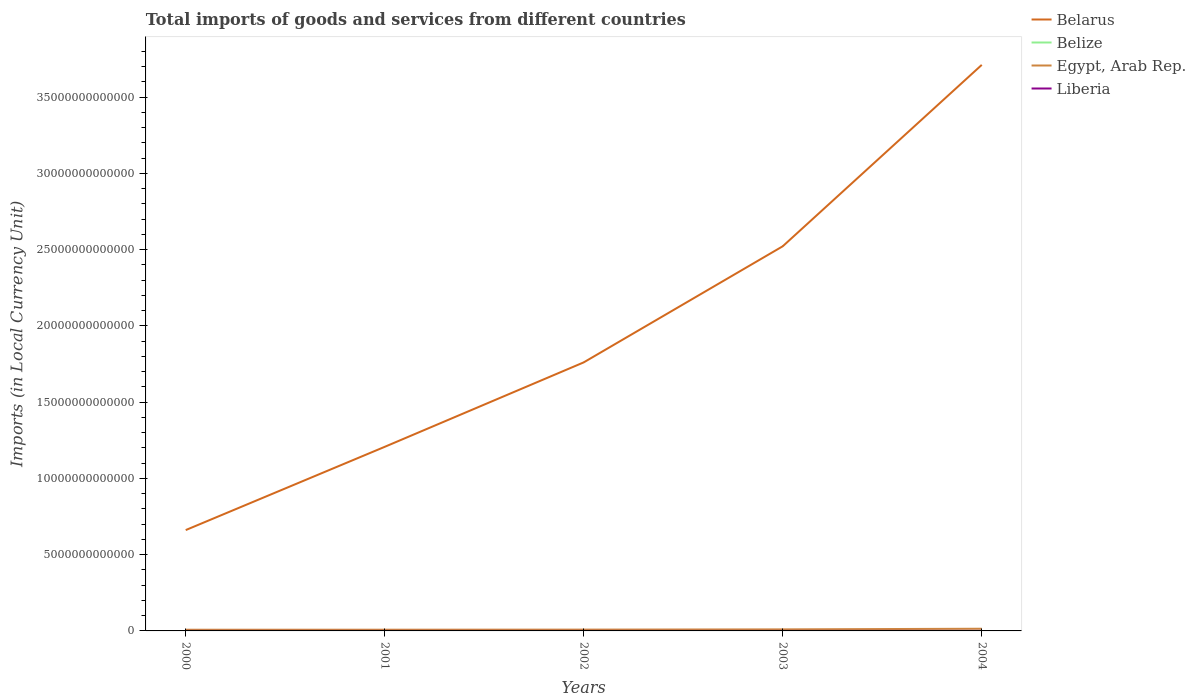How many different coloured lines are there?
Provide a short and direct response. 4. Does the line corresponding to Belarus intersect with the line corresponding to Belize?
Keep it short and to the point. No. Across all years, what is the maximum Amount of goods and services imports in Liberia?
Make the answer very short. 1.49e+08. In which year was the Amount of goods and services imports in Liberia maximum?
Provide a short and direct response. 2003. What is the total Amount of goods and services imports in Belarus in the graph?
Your answer should be compact. -1.10e+13. What is the difference between the highest and the second highest Amount of goods and services imports in Liberia?
Make the answer very short. 9.09e+08. How many lines are there?
Your answer should be very brief. 4. What is the difference between two consecutive major ticks on the Y-axis?
Your answer should be very brief. 5.00e+12. Are the values on the major ticks of Y-axis written in scientific E-notation?
Offer a terse response. No. How many legend labels are there?
Make the answer very short. 4. How are the legend labels stacked?
Provide a succinct answer. Vertical. What is the title of the graph?
Your answer should be very brief. Total imports of goods and services from different countries. Does "Czech Republic" appear as one of the legend labels in the graph?
Offer a terse response. No. What is the label or title of the X-axis?
Provide a short and direct response. Years. What is the label or title of the Y-axis?
Keep it short and to the point. Imports (in Local Currency Unit). What is the Imports (in Local Currency Unit) in Belarus in 2000?
Your answer should be very brief. 6.61e+12. What is the Imports (in Local Currency Unit) of Belize in 2000?
Give a very brief answer. 1.23e+09. What is the Imports (in Local Currency Unit) in Egypt, Arab Rep. in 2000?
Ensure brevity in your answer.  7.76e+1. What is the Imports (in Local Currency Unit) in Liberia in 2000?
Offer a very short reply. 2.06e+08. What is the Imports (in Local Currency Unit) in Belarus in 2001?
Offer a terse response. 1.21e+13. What is the Imports (in Local Currency Unit) in Belize in 2001?
Your answer should be compact. 1.20e+09. What is the Imports (in Local Currency Unit) in Egypt, Arab Rep. in 2001?
Ensure brevity in your answer.  8.01e+1. What is the Imports (in Local Currency Unit) of Liberia in 2001?
Your response must be concise. 1.64e+08. What is the Imports (in Local Currency Unit) of Belarus in 2002?
Your response must be concise. 1.76e+13. What is the Imports (in Local Currency Unit) in Belize in 2002?
Your answer should be compact. 1.23e+09. What is the Imports (in Local Currency Unit) of Egypt, Arab Rep. in 2002?
Ensure brevity in your answer.  8.59e+1. What is the Imports (in Local Currency Unit) of Liberia in 2002?
Offer a terse response. 1.67e+08. What is the Imports (in Local Currency Unit) in Belarus in 2003?
Offer a very short reply. 2.52e+13. What is the Imports (in Local Currency Unit) of Belize in 2003?
Offer a terse response. 1.31e+09. What is the Imports (in Local Currency Unit) in Egypt, Arab Rep. in 2003?
Your response must be concise. 1.02e+11. What is the Imports (in Local Currency Unit) of Liberia in 2003?
Make the answer very short. 1.49e+08. What is the Imports (in Local Currency Unit) in Belarus in 2004?
Your answer should be very brief. 3.71e+13. What is the Imports (in Local Currency Unit) in Belize in 2004?
Your answer should be very brief. 1.24e+09. What is the Imports (in Local Currency Unit) in Egypt, Arab Rep. in 2004?
Your response must be concise. 1.44e+11. What is the Imports (in Local Currency Unit) in Liberia in 2004?
Your answer should be compact. 1.06e+09. Across all years, what is the maximum Imports (in Local Currency Unit) of Belarus?
Make the answer very short. 3.71e+13. Across all years, what is the maximum Imports (in Local Currency Unit) in Belize?
Offer a terse response. 1.31e+09. Across all years, what is the maximum Imports (in Local Currency Unit) in Egypt, Arab Rep.?
Your answer should be compact. 1.44e+11. Across all years, what is the maximum Imports (in Local Currency Unit) of Liberia?
Your response must be concise. 1.06e+09. Across all years, what is the minimum Imports (in Local Currency Unit) of Belarus?
Offer a terse response. 6.61e+12. Across all years, what is the minimum Imports (in Local Currency Unit) in Belize?
Offer a very short reply. 1.20e+09. Across all years, what is the minimum Imports (in Local Currency Unit) in Egypt, Arab Rep.?
Your answer should be compact. 7.76e+1. Across all years, what is the minimum Imports (in Local Currency Unit) of Liberia?
Ensure brevity in your answer.  1.49e+08. What is the total Imports (in Local Currency Unit) in Belarus in the graph?
Provide a succinct answer. 9.86e+13. What is the total Imports (in Local Currency Unit) of Belize in the graph?
Provide a short and direct response. 6.21e+09. What is the total Imports (in Local Currency Unit) in Egypt, Arab Rep. in the graph?
Offer a terse response. 4.89e+11. What is the total Imports (in Local Currency Unit) of Liberia in the graph?
Give a very brief answer. 1.74e+09. What is the difference between the Imports (in Local Currency Unit) in Belarus in 2000 and that in 2001?
Offer a terse response. -5.46e+12. What is the difference between the Imports (in Local Currency Unit) of Belize in 2000 and that in 2001?
Your answer should be compact. 2.11e+07. What is the difference between the Imports (in Local Currency Unit) in Egypt, Arab Rep. in 2000 and that in 2001?
Make the answer very short. -2.50e+09. What is the difference between the Imports (in Local Currency Unit) of Liberia in 2000 and that in 2001?
Keep it short and to the point. 4.23e+07. What is the difference between the Imports (in Local Currency Unit) in Belarus in 2000 and that in 2002?
Your answer should be very brief. -1.10e+13. What is the difference between the Imports (in Local Currency Unit) of Belize in 2000 and that in 2002?
Your answer should be very brief. -7.40e+06. What is the difference between the Imports (in Local Currency Unit) in Egypt, Arab Rep. in 2000 and that in 2002?
Your answer should be very brief. -8.30e+09. What is the difference between the Imports (in Local Currency Unit) in Liberia in 2000 and that in 2002?
Provide a short and direct response. 3.89e+07. What is the difference between the Imports (in Local Currency Unit) in Belarus in 2000 and that in 2003?
Give a very brief answer. -1.86e+13. What is the difference between the Imports (in Local Currency Unit) of Belize in 2000 and that in 2003?
Your answer should be compact. -8.00e+07. What is the difference between the Imports (in Local Currency Unit) of Egypt, Arab Rep. in 2000 and that in 2003?
Give a very brief answer. -2.42e+1. What is the difference between the Imports (in Local Currency Unit) in Liberia in 2000 and that in 2003?
Your response must be concise. 5.68e+07. What is the difference between the Imports (in Local Currency Unit) in Belarus in 2000 and that in 2004?
Offer a very short reply. -3.05e+13. What is the difference between the Imports (in Local Currency Unit) of Belize in 2000 and that in 2004?
Offer a terse response. -1.20e+07. What is the difference between the Imports (in Local Currency Unit) of Egypt, Arab Rep. in 2000 and that in 2004?
Make the answer very short. -6.60e+1. What is the difference between the Imports (in Local Currency Unit) in Liberia in 2000 and that in 2004?
Your response must be concise. -8.52e+08. What is the difference between the Imports (in Local Currency Unit) of Belarus in 2001 and that in 2002?
Offer a terse response. -5.54e+12. What is the difference between the Imports (in Local Currency Unit) in Belize in 2001 and that in 2002?
Keep it short and to the point. -2.85e+07. What is the difference between the Imports (in Local Currency Unit) of Egypt, Arab Rep. in 2001 and that in 2002?
Ensure brevity in your answer.  -5.80e+09. What is the difference between the Imports (in Local Currency Unit) of Liberia in 2001 and that in 2002?
Ensure brevity in your answer.  -3.44e+06. What is the difference between the Imports (in Local Currency Unit) of Belarus in 2001 and that in 2003?
Your response must be concise. -1.32e+13. What is the difference between the Imports (in Local Currency Unit) in Belize in 2001 and that in 2003?
Offer a terse response. -1.01e+08. What is the difference between the Imports (in Local Currency Unit) in Egypt, Arab Rep. in 2001 and that in 2003?
Make the answer very short. -2.17e+1. What is the difference between the Imports (in Local Currency Unit) of Liberia in 2001 and that in 2003?
Provide a succinct answer. 1.45e+07. What is the difference between the Imports (in Local Currency Unit) of Belarus in 2001 and that in 2004?
Provide a short and direct response. -2.50e+13. What is the difference between the Imports (in Local Currency Unit) in Belize in 2001 and that in 2004?
Offer a very short reply. -3.31e+07. What is the difference between the Imports (in Local Currency Unit) of Egypt, Arab Rep. in 2001 and that in 2004?
Your response must be concise. -6.35e+1. What is the difference between the Imports (in Local Currency Unit) in Liberia in 2001 and that in 2004?
Your response must be concise. -8.94e+08. What is the difference between the Imports (in Local Currency Unit) of Belarus in 2002 and that in 2003?
Offer a very short reply. -7.61e+12. What is the difference between the Imports (in Local Currency Unit) in Belize in 2002 and that in 2003?
Provide a succinct answer. -7.26e+07. What is the difference between the Imports (in Local Currency Unit) in Egypt, Arab Rep. in 2002 and that in 2003?
Provide a short and direct response. -1.59e+1. What is the difference between the Imports (in Local Currency Unit) in Liberia in 2002 and that in 2003?
Your response must be concise. 1.79e+07. What is the difference between the Imports (in Local Currency Unit) of Belarus in 2002 and that in 2004?
Your answer should be compact. -1.95e+13. What is the difference between the Imports (in Local Currency Unit) in Belize in 2002 and that in 2004?
Provide a succinct answer. -4.60e+06. What is the difference between the Imports (in Local Currency Unit) in Egypt, Arab Rep. in 2002 and that in 2004?
Give a very brief answer. -5.77e+1. What is the difference between the Imports (in Local Currency Unit) of Liberia in 2002 and that in 2004?
Make the answer very short. -8.91e+08. What is the difference between the Imports (in Local Currency Unit) in Belarus in 2003 and that in 2004?
Offer a terse response. -1.19e+13. What is the difference between the Imports (in Local Currency Unit) of Belize in 2003 and that in 2004?
Provide a succinct answer. 6.80e+07. What is the difference between the Imports (in Local Currency Unit) in Egypt, Arab Rep. in 2003 and that in 2004?
Keep it short and to the point. -4.18e+1. What is the difference between the Imports (in Local Currency Unit) of Liberia in 2003 and that in 2004?
Provide a short and direct response. -9.09e+08. What is the difference between the Imports (in Local Currency Unit) of Belarus in 2000 and the Imports (in Local Currency Unit) of Belize in 2001?
Offer a terse response. 6.61e+12. What is the difference between the Imports (in Local Currency Unit) in Belarus in 2000 and the Imports (in Local Currency Unit) in Egypt, Arab Rep. in 2001?
Your response must be concise. 6.53e+12. What is the difference between the Imports (in Local Currency Unit) in Belarus in 2000 and the Imports (in Local Currency Unit) in Liberia in 2001?
Provide a short and direct response. 6.61e+12. What is the difference between the Imports (in Local Currency Unit) in Belize in 2000 and the Imports (in Local Currency Unit) in Egypt, Arab Rep. in 2001?
Keep it short and to the point. -7.89e+1. What is the difference between the Imports (in Local Currency Unit) of Belize in 2000 and the Imports (in Local Currency Unit) of Liberia in 2001?
Give a very brief answer. 1.06e+09. What is the difference between the Imports (in Local Currency Unit) in Egypt, Arab Rep. in 2000 and the Imports (in Local Currency Unit) in Liberia in 2001?
Offer a terse response. 7.74e+1. What is the difference between the Imports (in Local Currency Unit) in Belarus in 2000 and the Imports (in Local Currency Unit) in Belize in 2002?
Give a very brief answer. 6.61e+12. What is the difference between the Imports (in Local Currency Unit) in Belarus in 2000 and the Imports (in Local Currency Unit) in Egypt, Arab Rep. in 2002?
Your answer should be compact. 6.53e+12. What is the difference between the Imports (in Local Currency Unit) of Belarus in 2000 and the Imports (in Local Currency Unit) of Liberia in 2002?
Make the answer very short. 6.61e+12. What is the difference between the Imports (in Local Currency Unit) in Belize in 2000 and the Imports (in Local Currency Unit) in Egypt, Arab Rep. in 2002?
Give a very brief answer. -8.47e+1. What is the difference between the Imports (in Local Currency Unit) in Belize in 2000 and the Imports (in Local Currency Unit) in Liberia in 2002?
Offer a very short reply. 1.06e+09. What is the difference between the Imports (in Local Currency Unit) in Egypt, Arab Rep. in 2000 and the Imports (in Local Currency Unit) in Liberia in 2002?
Your response must be concise. 7.74e+1. What is the difference between the Imports (in Local Currency Unit) in Belarus in 2000 and the Imports (in Local Currency Unit) in Belize in 2003?
Make the answer very short. 6.61e+12. What is the difference between the Imports (in Local Currency Unit) in Belarus in 2000 and the Imports (in Local Currency Unit) in Egypt, Arab Rep. in 2003?
Ensure brevity in your answer.  6.51e+12. What is the difference between the Imports (in Local Currency Unit) of Belarus in 2000 and the Imports (in Local Currency Unit) of Liberia in 2003?
Your response must be concise. 6.61e+12. What is the difference between the Imports (in Local Currency Unit) in Belize in 2000 and the Imports (in Local Currency Unit) in Egypt, Arab Rep. in 2003?
Ensure brevity in your answer.  -1.01e+11. What is the difference between the Imports (in Local Currency Unit) of Belize in 2000 and the Imports (in Local Currency Unit) of Liberia in 2003?
Your answer should be very brief. 1.08e+09. What is the difference between the Imports (in Local Currency Unit) of Egypt, Arab Rep. in 2000 and the Imports (in Local Currency Unit) of Liberia in 2003?
Provide a short and direct response. 7.75e+1. What is the difference between the Imports (in Local Currency Unit) of Belarus in 2000 and the Imports (in Local Currency Unit) of Belize in 2004?
Your answer should be compact. 6.61e+12. What is the difference between the Imports (in Local Currency Unit) of Belarus in 2000 and the Imports (in Local Currency Unit) of Egypt, Arab Rep. in 2004?
Your answer should be very brief. 6.47e+12. What is the difference between the Imports (in Local Currency Unit) in Belarus in 2000 and the Imports (in Local Currency Unit) in Liberia in 2004?
Your answer should be very brief. 6.61e+12. What is the difference between the Imports (in Local Currency Unit) of Belize in 2000 and the Imports (in Local Currency Unit) of Egypt, Arab Rep. in 2004?
Your answer should be very brief. -1.42e+11. What is the difference between the Imports (in Local Currency Unit) of Belize in 2000 and the Imports (in Local Currency Unit) of Liberia in 2004?
Make the answer very short. 1.68e+08. What is the difference between the Imports (in Local Currency Unit) in Egypt, Arab Rep. in 2000 and the Imports (in Local Currency Unit) in Liberia in 2004?
Offer a terse response. 7.65e+1. What is the difference between the Imports (in Local Currency Unit) of Belarus in 2001 and the Imports (in Local Currency Unit) of Belize in 2002?
Keep it short and to the point. 1.21e+13. What is the difference between the Imports (in Local Currency Unit) of Belarus in 2001 and the Imports (in Local Currency Unit) of Egypt, Arab Rep. in 2002?
Provide a short and direct response. 1.20e+13. What is the difference between the Imports (in Local Currency Unit) in Belarus in 2001 and the Imports (in Local Currency Unit) in Liberia in 2002?
Offer a terse response. 1.21e+13. What is the difference between the Imports (in Local Currency Unit) of Belize in 2001 and the Imports (in Local Currency Unit) of Egypt, Arab Rep. in 2002?
Provide a succinct answer. -8.47e+1. What is the difference between the Imports (in Local Currency Unit) of Belize in 2001 and the Imports (in Local Currency Unit) of Liberia in 2002?
Provide a succinct answer. 1.04e+09. What is the difference between the Imports (in Local Currency Unit) in Egypt, Arab Rep. in 2001 and the Imports (in Local Currency Unit) in Liberia in 2002?
Offer a very short reply. 7.99e+1. What is the difference between the Imports (in Local Currency Unit) in Belarus in 2001 and the Imports (in Local Currency Unit) in Belize in 2003?
Offer a very short reply. 1.21e+13. What is the difference between the Imports (in Local Currency Unit) in Belarus in 2001 and the Imports (in Local Currency Unit) in Egypt, Arab Rep. in 2003?
Your answer should be very brief. 1.20e+13. What is the difference between the Imports (in Local Currency Unit) in Belarus in 2001 and the Imports (in Local Currency Unit) in Liberia in 2003?
Make the answer very short. 1.21e+13. What is the difference between the Imports (in Local Currency Unit) of Belize in 2001 and the Imports (in Local Currency Unit) of Egypt, Arab Rep. in 2003?
Offer a terse response. -1.01e+11. What is the difference between the Imports (in Local Currency Unit) of Belize in 2001 and the Imports (in Local Currency Unit) of Liberia in 2003?
Keep it short and to the point. 1.06e+09. What is the difference between the Imports (in Local Currency Unit) in Egypt, Arab Rep. in 2001 and the Imports (in Local Currency Unit) in Liberia in 2003?
Provide a short and direct response. 8.00e+1. What is the difference between the Imports (in Local Currency Unit) in Belarus in 2001 and the Imports (in Local Currency Unit) in Belize in 2004?
Provide a succinct answer. 1.21e+13. What is the difference between the Imports (in Local Currency Unit) in Belarus in 2001 and the Imports (in Local Currency Unit) in Egypt, Arab Rep. in 2004?
Offer a very short reply. 1.19e+13. What is the difference between the Imports (in Local Currency Unit) in Belarus in 2001 and the Imports (in Local Currency Unit) in Liberia in 2004?
Ensure brevity in your answer.  1.21e+13. What is the difference between the Imports (in Local Currency Unit) of Belize in 2001 and the Imports (in Local Currency Unit) of Egypt, Arab Rep. in 2004?
Your response must be concise. -1.42e+11. What is the difference between the Imports (in Local Currency Unit) in Belize in 2001 and the Imports (in Local Currency Unit) in Liberia in 2004?
Your answer should be very brief. 1.47e+08. What is the difference between the Imports (in Local Currency Unit) in Egypt, Arab Rep. in 2001 and the Imports (in Local Currency Unit) in Liberia in 2004?
Keep it short and to the point. 7.90e+1. What is the difference between the Imports (in Local Currency Unit) of Belarus in 2002 and the Imports (in Local Currency Unit) of Belize in 2003?
Your response must be concise. 1.76e+13. What is the difference between the Imports (in Local Currency Unit) in Belarus in 2002 and the Imports (in Local Currency Unit) in Egypt, Arab Rep. in 2003?
Give a very brief answer. 1.75e+13. What is the difference between the Imports (in Local Currency Unit) of Belarus in 2002 and the Imports (in Local Currency Unit) of Liberia in 2003?
Provide a short and direct response. 1.76e+13. What is the difference between the Imports (in Local Currency Unit) of Belize in 2002 and the Imports (in Local Currency Unit) of Egypt, Arab Rep. in 2003?
Provide a short and direct response. -1.01e+11. What is the difference between the Imports (in Local Currency Unit) of Belize in 2002 and the Imports (in Local Currency Unit) of Liberia in 2003?
Make the answer very short. 1.08e+09. What is the difference between the Imports (in Local Currency Unit) in Egypt, Arab Rep. in 2002 and the Imports (in Local Currency Unit) in Liberia in 2003?
Give a very brief answer. 8.58e+1. What is the difference between the Imports (in Local Currency Unit) in Belarus in 2002 and the Imports (in Local Currency Unit) in Belize in 2004?
Provide a succinct answer. 1.76e+13. What is the difference between the Imports (in Local Currency Unit) of Belarus in 2002 and the Imports (in Local Currency Unit) of Egypt, Arab Rep. in 2004?
Offer a very short reply. 1.75e+13. What is the difference between the Imports (in Local Currency Unit) of Belarus in 2002 and the Imports (in Local Currency Unit) of Liberia in 2004?
Provide a short and direct response. 1.76e+13. What is the difference between the Imports (in Local Currency Unit) of Belize in 2002 and the Imports (in Local Currency Unit) of Egypt, Arab Rep. in 2004?
Give a very brief answer. -1.42e+11. What is the difference between the Imports (in Local Currency Unit) in Belize in 2002 and the Imports (in Local Currency Unit) in Liberia in 2004?
Your answer should be compact. 1.75e+08. What is the difference between the Imports (in Local Currency Unit) of Egypt, Arab Rep. in 2002 and the Imports (in Local Currency Unit) of Liberia in 2004?
Ensure brevity in your answer.  8.48e+1. What is the difference between the Imports (in Local Currency Unit) in Belarus in 2003 and the Imports (in Local Currency Unit) in Belize in 2004?
Keep it short and to the point. 2.52e+13. What is the difference between the Imports (in Local Currency Unit) in Belarus in 2003 and the Imports (in Local Currency Unit) in Egypt, Arab Rep. in 2004?
Provide a short and direct response. 2.51e+13. What is the difference between the Imports (in Local Currency Unit) of Belarus in 2003 and the Imports (in Local Currency Unit) of Liberia in 2004?
Your answer should be compact. 2.52e+13. What is the difference between the Imports (in Local Currency Unit) in Belize in 2003 and the Imports (in Local Currency Unit) in Egypt, Arab Rep. in 2004?
Give a very brief answer. -1.42e+11. What is the difference between the Imports (in Local Currency Unit) in Belize in 2003 and the Imports (in Local Currency Unit) in Liberia in 2004?
Make the answer very short. 2.48e+08. What is the difference between the Imports (in Local Currency Unit) in Egypt, Arab Rep. in 2003 and the Imports (in Local Currency Unit) in Liberia in 2004?
Ensure brevity in your answer.  1.01e+11. What is the average Imports (in Local Currency Unit) in Belarus per year?
Provide a short and direct response. 1.97e+13. What is the average Imports (in Local Currency Unit) of Belize per year?
Ensure brevity in your answer.  1.24e+09. What is the average Imports (in Local Currency Unit) of Egypt, Arab Rep. per year?
Give a very brief answer. 9.78e+1. What is the average Imports (in Local Currency Unit) in Liberia per year?
Keep it short and to the point. 3.49e+08. In the year 2000, what is the difference between the Imports (in Local Currency Unit) of Belarus and Imports (in Local Currency Unit) of Belize?
Offer a very short reply. 6.61e+12. In the year 2000, what is the difference between the Imports (in Local Currency Unit) in Belarus and Imports (in Local Currency Unit) in Egypt, Arab Rep.?
Your answer should be compact. 6.54e+12. In the year 2000, what is the difference between the Imports (in Local Currency Unit) of Belarus and Imports (in Local Currency Unit) of Liberia?
Your answer should be very brief. 6.61e+12. In the year 2000, what is the difference between the Imports (in Local Currency Unit) of Belize and Imports (in Local Currency Unit) of Egypt, Arab Rep.?
Keep it short and to the point. -7.64e+1. In the year 2000, what is the difference between the Imports (in Local Currency Unit) in Belize and Imports (in Local Currency Unit) in Liberia?
Your response must be concise. 1.02e+09. In the year 2000, what is the difference between the Imports (in Local Currency Unit) in Egypt, Arab Rep. and Imports (in Local Currency Unit) in Liberia?
Ensure brevity in your answer.  7.74e+1. In the year 2001, what is the difference between the Imports (in Local Currency Unit) in Belarus and Imports (in Local Currency Unit) in Belize?
Your answer should be compact. 1.21e+13. In the year 2001, what is the difference between the Imports (in Local Currency Unit) of Belarus and Imports (in Local Currency Unit) of Egypt, Arab Rep.?
Make the answer very short. 1.20e+13. In the year 2001, what is the difference between the Imports (in Local Currency Unit) in Belarus and Imports (in Local Currency Unit) in Liberia?
Provide a succinct answer. 1.21e+13. In the year 2001, what is the difference between the Imports (in Local Currency Unit) in Belize and Imports (in Local Currency Unit) in Egypt, Arab Rep.?
Give a very brief answer. -7.89e+1. In the year 2001, what is the difference between the Imports (in Local Currency Unit) of Belize and Imports (in Local Currency Unit) of Liberia?
Ensure brevity in your answer.  1.04e+09. In the year 2001, what is the difference between the Imports (in Local Currency Unit) of Egypt, Arab Rep. and Imports (in Local Currency Unit) of Liberia?
Provide a short and direct response. 7.99e+1. In the year 2002, what is the difference between the Imports (in Local Currency Unit) in Belarus and Imports (in Local Currency Unit) in Belize?
Provide a succinct answer. 1.76e+13. In the year 2002, what is the difference between the Imports (in Local Currency Unit) of Belarus and Imports (in Local Currency Unit) of Egypt, Arab Rep.?
Your answer should be compact. 1.75e+13. In the year 2002, what is the difference between the Imports (in Local Currency Unit) in Belarus and Imports (in Local Currency Unit) in Liberia?
Give a very brief answer. 1.76e+13. In the year 2002, what is the difference between the Imports (in Local Currency Unit) of Belize and Imports (in Local Currency Unit) of Egypt, Arab Rep.?
Keep it short and to the point. -8.47e+1. In the year 2002, what is the difference between the Imports (in Local Currency Unit) in Belize and Imports (in Local Currency Unit) in Liberia?
Your response must be concise. 1.07e+09. In the year 2002, what is the difference between the Imports (in Local Currency Unit) of Egypt, Arab Rep. and Imports (in Local Currency Unit) of Liberia?
Your answer should be very brief. 8.57e+1. In the year 2003, what is the difference between the Imports (in Local Currency Unit) of Belarus and Imports (in Local Currency Unit) of Belize?
Your response must be concise. 2.52e+13. In the year 2003, what is the difference between the Imports (in Local Currency Unit) of Belarus and Imports (in Local Currency Unit) of Egypt, Arab Rep.?
Ensure brevity in your answer.  2.51e+13. In the year 2003, what is the difference between the Imports (in Local Currency Unit) of Belarus and Imports (in Local Currency Unit) of Liberia?
Keep it short and to the point. 2.52e+13. In the year 2003, what is the difference between the Imports (in Local Currency Unit) of Belize and Imports (in Local Currency Unit) of Egypt, Arab Rep.?
Your answer should be very brief. -1.00e+11. In the year 2003, what is the difference between the Imports (in Local Currency Unit) of Belize and Imports (in Local Currency Unit) of Liberia?
Offer a terse response. 1.16e+09. In the year 2003, what is the difference between the Imports (in Local Currency Unit) of Egypt, Arab Rep. and Imports (in Local Currency Unit) of Liberia?
Ensure brevity in your answer.  1.02e+11. In the year 2004, what is the difference between the Imports (in Local Currency Unit) in Belarus and Imports (in Local Currency Unit) in Belize?
Your answer should be very brief. 3.71e+13. In the year 2004, what is the difference between the Imports (in Local Currency Unit) of Belarus and Imports (in Local Currency Unit) of Egypt, Arab Rep.?
Keep it short and to the point. 3.70e+13. In the year 2004, what is the difference between the Imports (in Local Currency Unit) of Belarus and Imports (in Local Currency Unit) of Liberia?
Make the answer very short. 3.71e+13. In the year 2004, what is the difference between the Imports (in Local Currency Unit) in Belize and Imports (in Local Currency Unit) in Egypt, Arab Rep.?
Keep it short and to the point. -1.42e+11. In the year 2004, what is the difference between the Imports (in Local Currency Unit) of Belize and Imports (in Local Currency Unit) of Liberia?
Ensure brevity in your answer.  1.80e+08. In the year 2004, what is the difference between the Imports (in Local Currency Unit) in Egypt, Arab Rep. and Imports (in Local Currency Unit) in Liberia?
Provide a succinct answer. 1.43e+11. What is the ratio of the Imports (in Local Currency Unit) in Belarus in 2000 to that in 2001?
Make the answer very short. 0.55. What is the ratio of the Imports (in Local Currency Unit) of Belize in 2000 to that in 2001?
Provide a succinct answer. 1.02. What is the ratio of the Imports (in Local Currency Unit) in Egypt, Arab Rep. in 2000 to that in 2001?
Keep it short and to the point. 0.97. What is the ratio of the Imports (in Local Currency Unit) of Liberia in 2000 to that in 2001?
Provide a short and direct response. 1.26. What is the ratio of the Imports (in Local Currency Unit) in Belarus in 2000 to that in 2002?
Keep it short and to the point. 0.38. What is the ratio of the Imports (in Local Currency Unit) in Belize in 2000 to that in 2002?
Provide a short and direct response. 0.99. What is the ratio of the Imports (in Local Currency Unit) of Egypt, Arab Rep. in 2000 to that in 2002?
Offer a terse response. 0.9. What is the ratio of the Imports (in Local Currency Unit) of Liberia in 2000 to that in 2002?
Give a very brief answer. 1.23. What is the ratio of the Imports (in Local Currency Unit) in Belarus in 2000 to that in 2003?
Give a very brief answer. 0.26. What is the ratio of the Imports (in Local Currency Unit) in Belize in 2000 to that in 2003?
Give a very brief answer. 0.94. What is the ratio of the Imports (in Local Currency Unit) of Egypt, Arab Rep. in 2000 to that in 2003?
Your answer should be compact. 0.76. What is the ratio of the Imports (in Local Currency Unit) in Liberia in 2000 to that in 2003?
Keep it short and to the point. 1.38. What is the ratio of the Imports (in Local Currency Unit) of Belarus in 2000 to that in 2004?
Give a very brief answer. 0.18. What is the ratio of the Imports (in Local Currency Unit) in Belize in 2000 to that in 2004?
Offer a terse response. 0.99. What is the ratio of the Imports (in Local Currency Unit) of Egypt, Arab Rep. in 2000 to that in 2004?
Give a very brief answer. 0.54. What is the ratio of the Imports (in Local Currency Unit) of Liberia in 2000 to that in 2004?
Offer a very short reply. 0.19. What is the ratio of the Imports (in Local Currency Unit) of Belarus in 2001 to that in 2002?
Your response must be concise. 0.69. What is the ratio of the Imports (in Local Currency Unit) in Belize in 2001 to that in 2002?
Your response must be concise. 0.98. What is the ratio of the Imports (in Local Currency Unit) of Egypt, Arab Rep. in 2001 to that in 2002?
Your answer should be compact. 0.93. What is the ratio of the Imports (in Local Currency Unit) of Liberia in 2001 to that in 2002?
Give a very brief answer. 0.98. What is the ratio of the Imports (in Local Currency Unit) of Belarus in 2001 to that in 2003?
Make the answer very short. 0.48. What is the ratio of the Imports (in Local Currency Unit) of Belize in 2001 to that in 2003?
Offer a terse response. 0.92. What is the ratio of the Imports (in Local Currency Unit) of Egypt, Arab Rep. in 2001 to that in 2003?
Your response must be concise. 0.79. What is the ratio of the Imports (in Local Currency Unit) of Liberia in 2001 to that in 2003?
Your response must be concise. 1.1. What is the ratio of the Imports (in Local Currency Unit) of Belarus in 2001 to that in 2004?
Provide a short and direct response. 0.33. What is the ratio of the Imports (in Local Currency Unit) in Belize in 2001 to that in 2004?
Ensure brevity in your answer.  0.97. What is the ratio of the Imports (in Local Currency Unit) of Egypt, Arab Rep. in 2001 to that in 2004?
Your response must be concise. 0.56. What is the ratio of the Imports (in Local Currency Unit) in Liberia in 2001 to that in 2004?
Your answer should be compact. 0.15. What is the ratio of the Imports (in Local Currency Unit) of Belarus in 2002 to that in 2003?
Give a very brief answer. 0.7. What is the ratio of the Imports (in Local Currency Unit) of Egypt, Arab Rep. in 2002 to that in 2003?
Your response must be concise. 0.84. What is the ratio of the Imports (in Local Currency Unit) in Liberia in 2002 to that in 2003?
Offer a terse response. 1.12. What is the ratio of the Imports (in Local Currency Unit) in Belarus in 2002 to that in 2004?
Give a very brief answer. 0.47. What is the ratio of the Imports (in Local Currency Unit) in Egypt, Arab Rep. in 2002 to that in 2004?
Provide a succinct answer. 0.6. What is the ratio of the Imports (in Local Currency Unit) of Liberia in 2002 to that in 2004?
Your answer should be very brief. 0.16. What is the ratio of the Imports (in Local Currency Unit) in Belarus in 2003 to that in 2004?
Provide a succinct answer. 0.68. What is the ratio of the Imports (in Local Currency Unit) in Belize in 2003 to that in 2004?
Your answer should be compact. 1.05. What is the ratio of the Imports (in Local Currency Unit) in Egypt, Arab Rep. in 2003 to that in 2004?
Give a very brief answer. 0.71. What is the ratio of the Imports (in Local Currency Unit) in Liberia in 2003 to that in 2004?
Your answer should be compact. 0.14. What is the difference between the highest and the second highest Imports (in Local Currency Unit) of Belarus?
Ensure brevity in your answer.  1.19e+13. What is the difference between the highest and the second highest Imports (in Local Currency Unit) of Belize?
Your response must be concise. 6.80e+07. What is the difference between the highest and the second highest Imports (in Local Currency Unit) in Egypt, Arab Rep.?
Provide a short and direct response. 4.18e+1. What is the difference between the highest and the second highest Imports (in Local Currency Unit) of Liberia?
Provide a succinct answer. 8.52e+08. What is the difference between the highest and the lowest Imports (in Local Currency Unit) in Belarus?
Ensure brevity in your answer.  3.05e+13. What is the difference between the highest and the lowest Imports (in Local Currency Unit) in Belize?
Your answer should be very brief. 1.01e+08. What is the difference between the highest and the lowest Imports (in Local Currency Unit) in Egypt, Arab Rep.?
Keep it short and to the point. 6.60e+1. What is the difference between the highest and the lowest Imports (in Local Currency Unit) of Liberia?
Make the answer very short. 9.09e+08. 